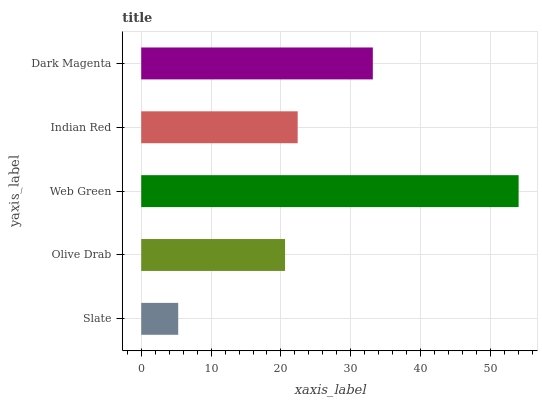Is Slate the minimum?
Answer yes or no. Yes. Is Web Green the maximum?
Answer yes or no. Yes. Is Olive Drab the minimum?
Answer yes or no. No. Is Olive Drab the maximum?
Answer yes or no. No. Is Olive Drab greater than Slate?
Answer yes or no. Yes. Is Slate less than Olive Drab?
Answer yes or no. Yes. Is Slate greater than Olive Drab?
Answer yes or no. No. Is Olive Drab less than Slate?
Answer yes or no. No. Is Indian Red the high median?
Answer yes or no. Yes. Is Indian Red the low median?
Answer yes or no. Yes. Is Olive Drab the high median?
Answer yes or no. No. Is Olive Drab the low median?
Answer yes or no. No. 